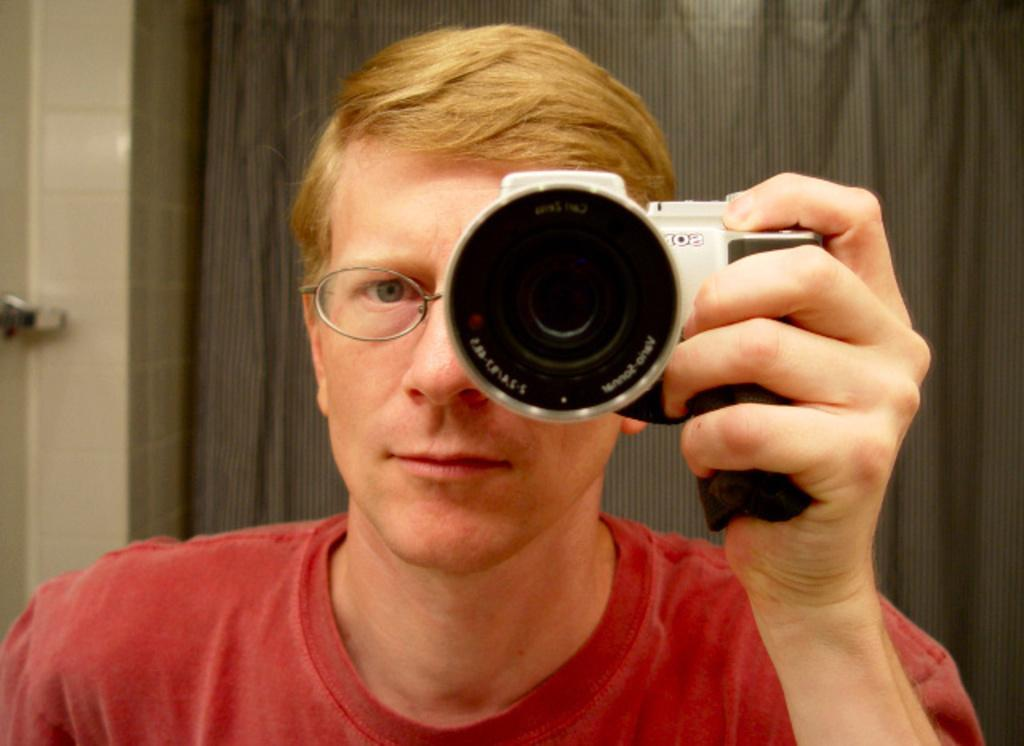Who or what is the main subject in the image? There is a person in the image. What is the person wearing? The person is wearing a red t-shirt. What is the person holding in the image? The person is holding a camera. What can be seen in the background of the image? There is a curtain in the background of the image. What type of silver form can be seen in the image? There is no silver form present in the image. What month is it in the image? The month cannot be determined from the image, as there is no indication of the time of year. 